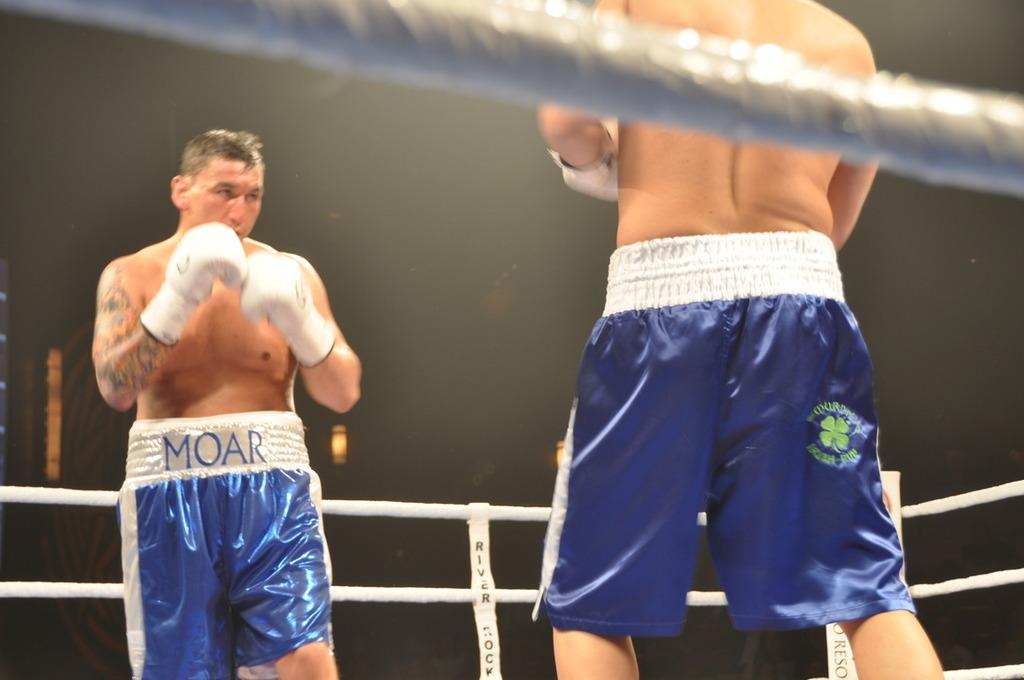Provide a one-sentence caption for the provided image. Two boxers, one of whom is wearing a pair of shorts with the word Moar on the back. 